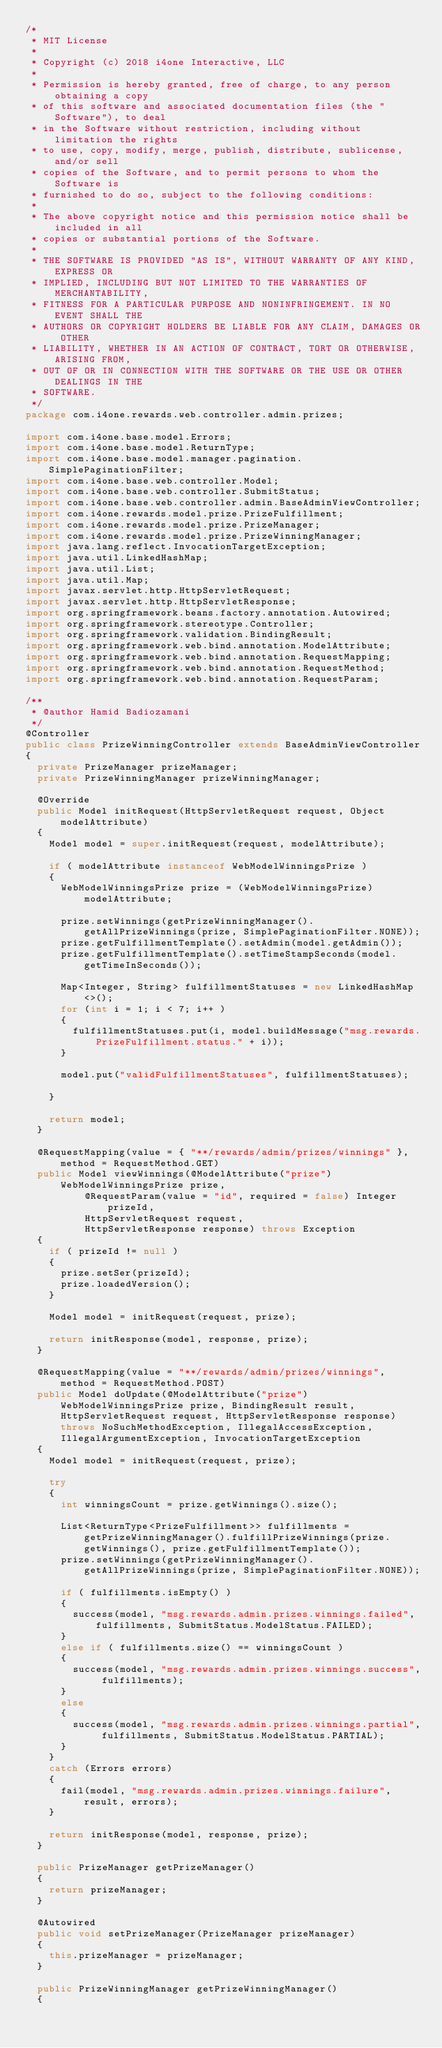<code> <loc_0><loc_0><loc_500><loc_500><_Java_>/*
 * MIT License
 * 
 * Copyright (c) 2018 i4one Interactive, LLC
 * 
 * Permission is hereby granted, free of charge, to any person obtaining a copy
 * of this software and associated documentation files (the "Software"), to deal
 * in the Software without restriction, including without limitation the rights
 * to use, copy, modify, merge, publish, distribute, sublicense, and/or sell
 * copies of the Software, and to permit persons to whom the Software is
 * furnished to do so, subject to the following conditions:
 * 
 * The above copyright notice and this permission notice shall be included in all
 * copies or substantial portions of the Software.
 * 
 * THE SOFTWARE IS PROVIDED "AS IS", WITHOUT WARRANTY OF ANY KIND, EXPRESS OR
 * IMPLIED, INCLUDING BUT NOT LIMITED TO THE WARRANTIES OF MERCHANTABILITY,
 * FITNESS FOR A PARTICULAR PURPOSE AND NONINFRINGEMENT. IN NO EVENT SHALL THE
 * AUTHORS OR COPYRIGHT HOLDERS BE LIABLE FOR ANY CLAIM, DAMAGES OR OTHER
 * LIABILITY, WHETHER IN AN ACTION OF CONTRACT, TORT OR OTHERWISE, ARISING FROM,
 * OUT OF OR IN CONNECTION WITH THE SOFTWARE OR THE USE OR OTHER DEALINGS IN THE
 * SOFTWARE.
 */
package com.i4one.rewards.web.controller.admin.prizes;

import com.i4one.base.model.Errors;
import com.i4one.base.model.ReturnType;
import com.i4one.base.model.manager.pagination.SimplePaginationFilter;
import com.i4one.base.web.controller.Model;
import com.i4one.base.web.controller.SubmitStatus;
import com.i4one.base.web.controller.admin.BaseAdminViewController;
import com.i4one.rewards.model.prize.PrizeFulfillment;
import com.i4one.rewards.model.prize.PrizeManager;
import com.i4one.rewards.model.prize.PrizeWinningManager;
import java.lang.reflect.InvocationTargetException;
import java.util.LinkedHashMap;
import java.util.List;
import java.util.Map;
import javax.servlet.http.HttpServletRequest;
import javax.servlet.http.HttpServletResponse;
import org.springframework.beans.factory.annotation.Autowired;
import org.springframework.stereotype.Controller;
import org.springframework.validation.BindingResult;
import org.springframework.web.bind.annotation.ModelAttribute;
import org.springframework.web.bind.annotation.RequestMapping;
import org.springframework.web.bind.annotation.RequestMethod;
import org.springframework.web.bind.annotation.RequestParam;

/**
 * @author Hamid Badiozamani
 */
@Controller
public class PrizeWinningController extends BaseAdminViewController
{
	private PrizeManager prizeManager;
	private PrizeWinningManager prizeWinningManager;

	@Override
	public Model initRequest(HttpServletRequest request, Object modelAttribute)
	{
		Model model = super.initRequest(request, modelAttribute);

		if ( modelAttribute instanceof WebModelWinningsPrize )
		{
			WebModelWinningsPrize prize = (WebModelWinningsPrize)modelAttribute;

			prize.setWinnings(getPrizeWinningManager().getAllPrizeWinnings(prize, SimplePaginationFilter.NONE));
			prize.getFulfillmentTemplate().setAdmin(model.getAdmin());
			prize.getFulfillmentTemplate().setTimeStampSeconds(model.getTimeInSeconds());

			Map<Integer, String> fulfillmentStatuses = new LinkedHashMap<>();
			for (int i = 1; i < 7; i++ )
			{
				fulfillmentStatuses.put(i, model.buildMessage("msg.rewards.PrizeFulfillment.status." + i));
			}

			model.put("validFulfillmentStatuses", fulfillmentStatuses);

		}

		return model;
	}
	
	@RequestMapping(value = { "**/rewards/admin/prizes/winnings" }, method = RequestMethod.GET)
	public Model viewWinnings(@ModelAttribute("prize") WebModelWinningsPrize prize,
					@RequestParam(value = "id", required = false) Integer prizeId,
					HttpServletRequest request,
					HttpServletResponse response) throws Exception
	{
		if ( prizeId != null )
		{
			prize.setSer(prizeId);
			prize.loadedVersion();
		}

		Model model = initRequest(request, prize);

		return initResponse(model, response, prize);
	}

	@RequestMapping(value = "**/rewards/admin/prizes/winnings", method = RequestMethod.POST)
	public Model doUpdate(@ModelAttribute("prize") WebModelWinningsPrize prize, BindingResult result, HttpServletRequest request, HttpServletResponse response) throws NoSuchMethodException, IllegalAccessException, IllegalArgumentException, InvocationTargetException
	{
		Model model = initRequest(request, prize);

		try
		{
			int winningsCount = prize.getWinnings().size();

			List<ReturnType<PrizeFulfillment>> fulfillments = getPrizeWinningManager().fulfillPrizeWinnings(prize.getWinnings(), prize.getFulfillmentTemplate());
			prize.setWinnings(getPrizeWinningManager().getAllPrizeWinnings(prize, SimplePaginationFilter.NONE));

			if ( fulfillments.isEmpty() )
			{
				success(model, "msg.rewards.admin.prizes.winnings.failed", fulfillments, SubmitStatus.ModelStatus.FAILED);
			}
			else if ( fulfillments.size() == winningsCount )
			{
				success(model, "msg.rewards.admin.prizes.winnings.success", fulfillments);
			}
			else
			{
				success(model, "msg.rewards.admin.prizes.winnings.partial", fulfillments, SubmitStatus.ModelStatus.PARTIAL);
			}
		}
		catch (Errors errors)
		{
			fail(model, "msg.rewards.admin.prizes.winnings.failure", result, errors);
		}

		return initResponse(model, response, prize);
	}

	public PrizeManager getPrizeManager()
	{
		return prizeManager;
	}

	@Autowired
	public void setPrizeManager(PrizeManager prizeManager)
	{
		this.prizeManager = prizeManager;
	}

	public PrizeWinningManager getPrizeWinningManager()
	{</code> 